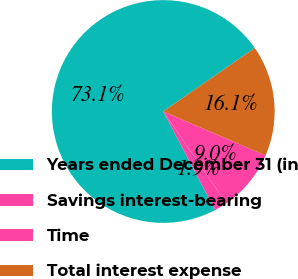Convert chart. <chart><loc_0><loc_0><loc_500><loc_500><pie_chart><fcel>Years ended December 31 (in<fcel>Savings interest-bearing<fcel>Time<fcel>Total interest expense<nl><fcel>73.07%<fcel>1.85%<fcel>8.98%<fcel>16.1%<nl></chart> 